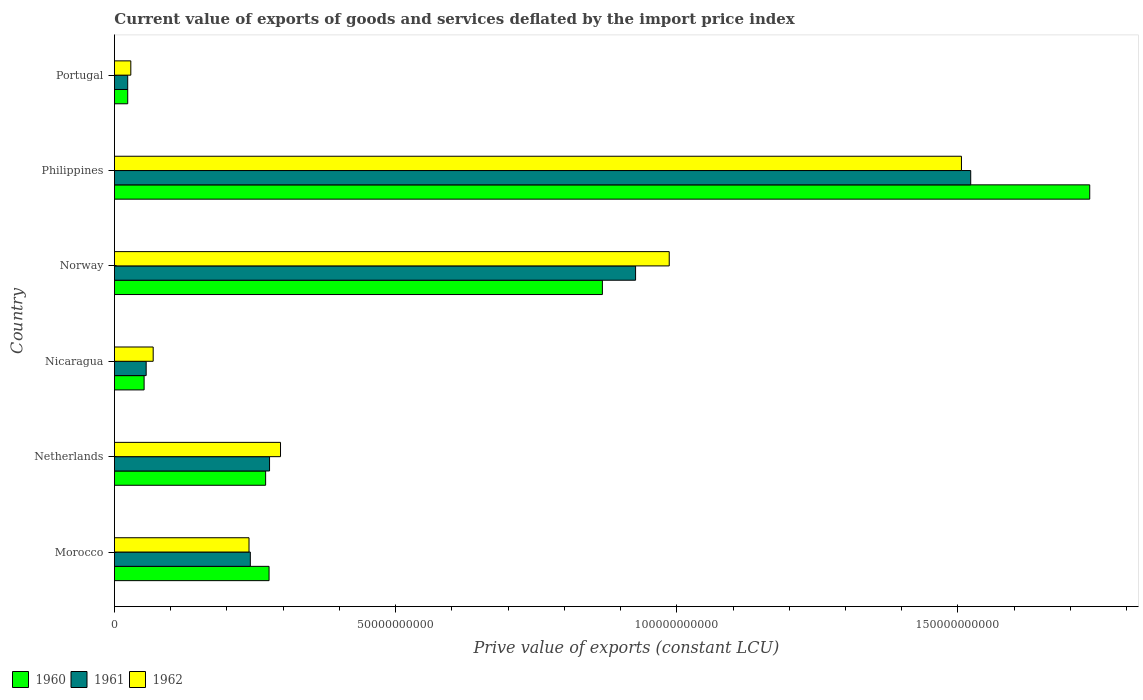How many groups of bars are there?
Make the answer very short. 6. How many bars are there on the 3rd tick from the bottom?
Give a very brief answer. 3. What is the prive value of exports in 1960 in Netherlands?
Make the answer very short. 2.69e+1. Across all countries, what is the maximum prive value of exports in 1962?
Keep it short and to the point. 1.51e+11. Across all countries, what is the minimum prive value of exports in 1960?
Offer a terse response. 2.36e+09. What is the total prive value of exports in 1961 in the graph?
Your response must be concise. 3.05e+11. What is the difference between the prive value of exports in 1962 in Netherlands and that in Norway?
Your answer should be very brief. -6.91e+1. What is the difference between the prive value of exports in 1962 in Philippines and the prive value of exports in 1961 in Portugal?
Provide a succinct answer. 1.48e+11. What is the average prive value of exports in 1962 per country?
Give a very brief answer. 5.21e+1. What is the difference between the prive value of exports in 1961 and prive value of exports in 1960 in Morocco?
Make the answer very short. -3.33e+09. In how many countries, is the prive value of exports in 1961 greater than 120000000000 LCU?
Ensure brevity in your answer.  1. What is the ratio of the prive value of exports in 1961 in Morocco to that in Netherlands?
Provide a short and direct response. 0.88. What is the difference between the highest and the second highest prive value of exports in 1961?
Provide a succinct answer. 5.96e+1. What is the difference between the highest and the lowest prive value of exports in 1962?
Make the answer very short. 1.48e+11. Is the sum of the prive value of exports in 1961 in Morocco and Portugal greater than the maximum prive value of exports in 1960 across all countries?
Your answer should be compact. No. What does the 2nd bar from the top in Philippines represents?
Offer a very short reply. 1961. What does the 1st bar from the bottom in Philippines represents?
Your answer should be compact. 1960. How many bars are there?
Ensure brevity in your answer.  18. How many countries are there in the graph?
Provide a short and direct response. 6. Are the values on the major ticks of X-axis written in scientific E-notation?
Give a very brief answer. No. Does the graph contain grids?
Your answer should be compact. No. What is the title of the graph?
Your answer should be very brief. Current value of exports of goods and services deflated by the import price index. What is the label or title of the X-axis?
Give a very brief answer. Prive value of exports (constant LCU). What is the Prive value of exports (constant LCU) of 1960 in Morocco?
Provide a short and direct response. 2.75e+1. What is the Prive value of exports (constant LCU) in 1961 in Morocco?
Ensure brevity in your answer.  2.42e+1. What is the Prive value of exports (constant LCU) of 1962 in Morocco?
Offer a terse response. 2.39e+1. What is the Prive value of exports (constant LCU) of 1960 in Netherlands?
Offer a terse response. 2.69e+1. What is the Prive value of exports (constant LCU) of 1961 in Netherlands?
Your answer should be very brief. 2.76e+1. What is the Prive value of exports (constant LCU) in 1962 in Netherlands?
Offer a very short reply. 2.95e+1. What is the Prive value of exports (constant LCU) of 1960 in Nicaragua?
Ensure brevity in your answer.  5.28e+09. What is the Prive value of exports (constant LCU) in 1961 in Nicaragua?
Provide a succinct answer. 5.65e+09. What is the Prive value of exports (constant LCU) in 1962 in Nicaragua?
Make the answer very short. 6.89e+09. What is the Prive value of exports (constant LCU) of 1960 in Norway?
Provide a short and direct response. 8.68e+1. What is the Prive value of exports (constant LCU) of 1961 in Norway?
Provide a succinct answer. 9.27e+1. What is the Prive value of exports (constant LCU) of 1962 in Norway?
Give a very brief answer. 9.87e+1. What is the Prive value of exports (constant LCU) of 1960 in Philippines?
Your response must be concise. 1.73e+11. What is the Prive value of exports (constant LCU) of 1961 in Philippines?
Offer a very short reply. 1.52e+11. What is the Prive value of exports (constant LCU) in 1962 in Philippines?
Your response must be concise. 1.51e+11. What is the Prive value of exports (constant LCU) in 1960 in Portugal?
Make the answer very short. 2.36e+09. What is the Prive value of exports (constant LCU) in 1961 in Portugal?
Offer a very short reply. 2.36e+09. What is the Prive value of exports (constant LCU) in 1962 in Portugal?
Ensure brevity in your answer.  2.91e+09. Across all countries, what is the maximum Prive value of exports (constant LCU) of 1960?
Offer a terse response. 1.73e+11. Across all countries, what is the maximum Prive value of exports (constant LCU) in 1961?
Give a very brief answer. 1.52e+11. Across all countries, what is the maximum Prive value of exports (constant LCU) of 1962?
Keep it short and to the point. 1.51e+11. Across all countries, what is the minimum Prive value of exports (constant LCU) in 1960?
Offer a very short reply. 2.36e+09. Across all countries, what is the minimum Prive value of exports (constant LCU) of 1961?
Your answer should be compact. 2.36e+09. Across all countries, what is the minimum Prive value of exports (constant LCU) in 1962?
Provide a short and direct response. 2.91e+09. What is the total Prive value of exports (constant LCU) in 1960 in the graph?
Keep it short and to the point. 3.22e+11. What is the total Prive value of exports (constant LCU) in 1961 in the graph?
Offer a terse response. 3.05e+11. What is the total Prive value of exports (constant LCU) in 1962 in the graph?
Keep it short and to the point. 3.13e+11. What is the difference between the Prive value of exports (constant LCU) of 1960 in Morocco and that in Netherlands?
Offer a terse response. 6.10e+08. What is the difference between the Prive value of exports (constant LCU) of 1961 in Morocco and that in Netherlands?
Give a very brief answer. -3.42e+09. What is the difference between the Prive value of exports (constant LCU) in 1962 in Morocco and that in Netherlands?
Ensure brevity in your answer.  -5.60e+09. What is the difference between the Prive value of exports (constant LCU) in 1960 in Morocco and that in Nicaragua?
Make the answer very short. 2.22e+1. What is the difference between the Prive value of exports (constant LCU) in 1961 in Morocco and that in Nicaragua?
Keep it short and to the point. 1.85e+1. What is the difference between the Prive value of exports (constant LCU) in 1962 in Morocco and that in Nicaragua?
Offer a terse response. 1.70e+1. What is the difference between the Prive value of exports (constant LCU) of 1960 in Morocco and that in Norway?
Make the answer very short. -5.93e+1. What is the difference between the Prive value of exports (constant LCU) of 1961 in Morocco and that in Norway?
Provide a succinct answer. -6.85e+1. What is the difference between the Prive value of exports (constant LCU) in 1962 in Morocco and that in Norway?
Offer a very short reply. -7.47e+1. What is the difference between the Prive value of exports (constant LCU) in 1960 in Morocco and that in Philippines?
Provide a succinct answer. -1.46e+11. What is the difference between the Prive value of exports (constant LCU) in 1961 in Morocco and that in Philippines?
Offer a terse response. -1.28e+11. What is the difference between the Prive value of exports (constant LCU) in 1962 in Morocco and that in Philippines?
Ensure brevity in your answer.  -1.27e+11. What is the difference between the Prive value of exports (constant LCU) of 1960 in Morocco and that in Portugal?
Make the answer very short. 2.51e+1. What is the difference between the Prive value of exports (constant LCU) in 1961 in Morocco and that in Portugal?
Provide a short and direct response. 2.18e+1. What is the difference between the Prive value of exports (constant LCU) of 1962 in Morocco and that in Portugal?
Your response must be concise. 2.10e+1. What is the difference between the Prive value of exports (constant LCU) in 1960 in Netherlands and that in Nicaragua?
Ensure brevity in your answer.  2.16e+1. What is the difference between the Prive value of exports (constant LCU) of 1961 in Netherlands and that in Nicaragua?
Keep it short and to the point. 2.19e+1. What is the difference between the Prive value of exports (constant LCU) in 1962 in Netherlands and that in Nicaragua?
Make the answer very short. 2.26e+1. What is the difference between the Prive value of exports (constant LCU) in 1960 in Netherlands and that in Norway?
Offer a terse response. -5.99e+1. What is the difference between the Prive value of exports (constant LCU) in 1961 in Netherlands and that in Norway?
Provide a succinct answer. -6.51e+1. What is the difference between the Prive value of exports (constant LCU) in 1962 in Netherlands and that in Norway?
Keep it short and to the point. -6.91e+1. What is the difference between the Prive value of exports (constant LCU) in 1960 in Netherlands and that in Philippines?
Your answer should be very brief. -1.47e+11. What is the difference between the Prive value of exports (constant LCU) in 1961 in Netherlands and that in Philippines?
Give a very brief answer. -1.25e+11. What is the difference between the Prive value of exports (constant LCU) of 1962 in Netherlands and that in Philippines?
Your answer should be compact. -1.21e+11. What is the difference between the Prive value of exports (constant LCU) in 1960 in Netherlands and that in Portugal?
Your response must be concise. 2.45e+1. What is the difference between the Prive value of exports (constant LCU) in 1961 in Netherlands and that in Portugal?
Offer a terse response. 2.52e+1. What is the difference between the Prive value of exports (constant LCU) in 1962 in Netherlands and that in Portugal?
Provide a succinct answer. 2.66e+1. What is the difference between the Prive value of exports (constant LCU) of 1960 in Nicaragua and that in Norway?
Make the answer very short. -8.15e+1. What is the difference between the Prive value of exports (constant LCU) of 1961 in Nicaragua and that in Norway?
Give a very brief answer. -8.70e+1. What is the difference between the Prive value of exports (constant LCU) of 1962 in Nicaragua and that in Norway?
Offer a very short reply. -9.18e+1. What is the difference between the Prive value of exports (constant LCU) of 1960 in Nicaragua and that in Philippines?
Offer a terse response. -1.68e+11. What is the difference between the Prive value of exports (constant LCU) of 1961 in Nicaragua and that in Philippines?
Offer a terse response. -1.47e+11. What is the difference between the Prive value of exports (constant LCU) in 1962 in Nicaragua and that in Philippines?
Your answer should be very brief. -1.44e+11. What is the difference between the Prive value of exports (constant LCU) in 1960 in Nicaragua and that in Portugal?
Make the answer very short. 2.92e+09. What is the difference between the Prive value of exports (constant LCU) of 1961 in Nicaragua and that in Portugal?
Ensure brevity in your answer.  3.29e+09. What is the difference between the Prive value of exports (constant LCU) of 1962 in Nicaragua and that in Portugal?
Make the answer very short. 3.98e+09. What is the difference between the Prive value of exports (constant LCU) of 1960 in Norway and that in Philippines?
Offer a terse response. -8.67e+1. What is the difference between the Prive value of exports (constant LCU) of 1961 in Norway and that in Philippines?
Your answer should be compact. -5.96e+1. What is the difference between the Prive value of exports (constant LCU) of 1962 in Norway and that in Philippines?
Give a very brief answer. -5.20e+1. What is the difference between the Prive value of exports (constant LCU) in 1960 in Norway and that in Portugal?
Ensure brevity in your answer.  8.44e+1. What is the difference between the Prive value of exports (constant LCU) in 1961 in Norway and that in Portugal?
Your response must be concise. 9.03e+1. What is the difference between the Prive value of exports (constant LCU) of 1962 in Norway and that in Portugal?
Your answer should be compact. 9.57e+1. What is the difference between the Prive value of exports (constant LCU) in 1960 in Philippines and that in Portugal?
Keep it short and to the point. 1.71e+11. What is the difference between the Prive value of exports (constant LCU) of 1961 in Philippines and that in Portugal?
Give a very brief answer. 1.50e+11. What is the difference between the Prive value of exports (constant LCU) of 1962 in Philippines and that in Portugal?
Give a very brief answer. 1.48e+11. What is the difference between the Prive value of exports (constant LCU) in 1960 in Morocco and the Prive value of exports (constant LCU) in 1961 in Netherlands?
Keep it short and to the point. -8.70e+07. What is the difference between the Prive value of exports (constant LCU) of 1960 in Morocco and the Prive value of exports (constant LCU) of 1962 in Netherlands?
Your response must be concise. -2.04e+09. What is the difference between the Prive value of exports (constant LCU) of 1961 in Morocco and the Prive value of exports (constant LCU) of 1962 in Netherlands?
Give a very brief answer. -5.37e+09. What is the difference between the Prive value of exports (constant LCU) in 1960 in Morocco and the Prive value of exports (constant LCU) in 1961 in Nicaragua?
Provide a succinct answer. 2.19e+1. What is the difference between the Prive value of exports (constant LCU) of 1960 in Morocco and the Prive value of exports (constant LCU) of 1962 in Nicaragua?
Give a very brief answer. 2.06e+1. What is the difference between the Prive value of exports (constant LCU) of 1961 in Morocco and the Prive value of exports (constant LCU) of 1962 in Nicaragua?
Keep it short and to the point. 1.73e+1. What is the difference between the Prive value of exports (constant LCU) in 1960 in Morocco and the Prive value of exports (constant LCU) in 1961 in Norway?
Provide a succinct answer. -6.52e+1. What is the difference between the Prive value of exports (constant LCU) in 1960 in Morocco and the Prive value of exports (constant LCU) in 1962 in Norway?
Provide a short and direct response. -7.12e+1. What is the difference between the Prive value of exports (constant LCU) in 1961 in Morocco and the Prive value of exports (constant LCU) in 1962 in Norway?
Keep it short and to the point. -7.45e+1. What is the difference between the Prive value of exports (constant LCU) in 1960 in Morocco and the Prive value of exports (constant LCU) in 1961 in Philippines?
Your answer should be compact. -1.25e+11. What is the difference between the Prive value of exports (constant LCU) in 1960 in Morocco and the Prive value of exports (constant LCU) in 1962 in Philippines?
Make the answer very short. -1.23e+11. What is the difference between the Prive value of exports (constant LCU) of 1961 in Morocco and the Prive value of exports (constant LCU) of 1962 in Philippines?
Offer a terse response. -1.26e+11. What is the difference between the Prive value of exports (constant LCU) in 1960 in Morocco and the Prive value of exports (constant LCU) in 1961 in Portugal?
Your answer should be very brief. 2.51e+1. What is the difference between the Prive value of exports (constant LCU) in 1960 in Morocco and the Prive value of exports (constant LCU) in 1962 in Portugal?
Provide a short and direct response. 2.46e+1. What is the difference between the Prive value of exports (constant LCU) of 1961 in Morocco and the Prive value of exports (constant LCU) of 1962 in Portugal?
Keep it short and to the point. 2.13e+1. What is the difference between the Prive value of exports (constant LCU) of 1960 in Netherlands and the Prive value of exports (constant LCU) of 1961 in Nicaragua?
Offer a very short reply. 2.12e+1. What is the difference between the Prive value of exports (constant LCU) in 1960 in Netherlands and the Prive value of exports (constant LCU) in 1962 in Nicaragua?
Your answer should be compact. 2.00e+1. What is the difference between the Prive value of exports (constant LCU) of 1961 in Netherlands and the Prive value of exports (constant LCU) of 1962 in Nicaragua?
Keep it short and to the point. 2.07e+1. What is the difference between the Prive value of exports (constant LCU) of 1960 in Netherlands and the Prive value of exports (constant LCU) of 1961 in Norway?
Provide a short and direct response. -6.58e+1. What is the difference between the Prive value of exports (constant LCU) in 1960 in Netherlands and the Prive value of exports (constant LCU) in 1962 in Norway?
Your answer should be very brief. -7.18e+1. What is the difference between the Prive value of exports (constant LCU) in 1961 in Netherlands and the Prive value of exports (constant LCU) in 1962 in Norway?
Keep it short and to the point. -7.11e+1. What is the difference between the Prive value of exports (constant LCU) in 1960 in Netherlands and the Prive value of exports (constant LCU) in 1961 in Philippines?
Offer a terse response. -1.25e+11. What is the difference between the Prive value of exports (constant LCU) of 1960 in Netherlands and the Prive value of exports (constant LCU) of 1962 in Philippines?
Provide a succinct answer. -1.24e+11. What is the difference between the Prive value of exports (constant LCU) in 1961 in Netherlands and the Prive value of exports (constant LCU) in 1962 in Philippines?
Your response must be concise. -1.23e+11. What is the difference between the Prive value of exports (constant LCU) in 1960 in Netherlands and the Prive value of exports (constant LCU) in 1961 in Portugal?
Your answer should be compact. 2.45e+1. What is the difference between the Prive value of exports (constant LCU) of 1960 in Netherlands and the Prive value of exports (constant LCU) of 1962 in Portugal?
Give a very brief answer. 2.40e+1. What is the difference between the Prive value of exports (constant LCU) in 1961 in Netherlands and the Prive value of exports (constant LCU) in 1962 in Portugal?
Offer a terse response. 2.47e+1. What is the difference between the Prive value of exports (constant LCU) of 1960 in Nicaragua and the Prive value of exports (constant LCU) of 1961 in Norway?
Your answer should be very brief. -8.74e+1. What is the difference between the Prive value of exports (constant LCU) of 1960 in Nicaragua and the Prive value of exports (constant LCU) of 1962 in Norway?
Offer a very short reply. -9.34e+1. What is the difference between the Prive value of exports (constant LCU) in 1961 in Nicaragua and the Prive value of exports (constant LCU) in 1962 in Norway?
Your response must be concise. -9.30e+1. What is the difference between the Prive value of exports (constant LCU) of 1960 in Nicaragua and the Prive value of exports (constant LCU) of 1961 in Philippines?
Provide a succinct answer. -1.47e+11. What is the difference between the Prive value of exports (constant LCU) in 1960 in Nicaragua and the Prive value of exports (constant LCU) in 1962 in Philippines?
Offer a terse response. -1.45e+11. What is the difference between the Prive value of exports (constant LCU) in 1961 in Nicaragua and the Prive value of exports (constant LCU) in 1962 in Philippines?
Provide a succinct answer. -1.45e+11. What is the difference between the Prive value of exports (constant LCU) of 1960 in Nicaragua and the Prive value of exports (constant LCU) of 1961 in Portugal?
Offer a very short reply. 2.92e+09. What is the difference between the Prive value of exports (constant LCU) of 1960 in Nicaragua and the Prive value of exports (constant LCU) of 1962 in Portugal?
Your answer should be compact. 2.37e+09. What is the difference between the Prive value of exports (constant LCU) in 1961 in Nicaragua and the Prive value of exports (constant LCU) in 1962 in Portugal?
Ensure brevity in your answer.  2.73e+09. What is the difference between the Prive value of exports (constant LCU) in 1960 in Norway and the Prive value of exports (constant LCU) in 1961 in Philippines?
Give a very brief answer. -6.55e+1. What is the difference between the Prive value of exports (constant LCU) of 1960 in Norway and the Prive value of exports (constant LCU) of 1962 in Philippines?
Your answer should be compact. -6.39e+1. What is the difference between the Prive value of exports (constant LCU) of 1961 in Norway and the Prive value of exports (constant LCU) of 1962 in Philippines?
Your answer should be very brief. -5.79e+1. What is the difference between the Prive value of exports (constant LCU) in 1960 in Norway and the Prive value of exports (constant LCU) in 1961 in Portugal?
Your answer should be compact. 8.44e+1. What is the difference between the Prive value of exports (constant LCU) in 1960 in Norway and the Prive value of exports (constant LCU) in 1962 in Portugal?
Ensure brevity in your answer.  8.39e+1. What is the difference between the Prive value of exports (constant LCU) in 1961 in Norway and the Prive value of exports (constant LCU) in 1962 in Portugal?
Ensure brevity in your answer.  8.98e+1. What is the difference between the Prive value of exports (constant LCU) in 1960 in Philippines and the Prive value of exports (constant LCU) in 1961 in Portugal?
Provide a succinct answer. 1.71e+11. What is the difference between the Prive value of exports (constant LCU) in 1960 in Philippines and the Prive value of exports (constant LCU) in 1962 in Portugal?
Ensure brevity in your answer.  1.71e+11. What is the difference between the Prive value of exports (constant LCU) in 1961 in Philippines and the Prive value of exports (constant LCU) in 1962 in Portugal?
Ensure brevity in your answer.  1.49e+11. What is the average Prive value of exports (constant LCU) in 1960 per country?
Provide a succinct answer. 5.37e+1. What is the average Prive value of exports (constant LCU) in 1961 per country?
Give a very brief answer. 5.08e+1. What is the average Prive value of exports (constant LCU) of 1962 per country?
Ensure brevity in your answer.  5.21e+1. What is the difference between the Prive value of exports (constant LCU) of 1960 and Prive value of exports (constant LCU) of 1961 in Morocco?
Your answer should be compact. 3.33e+09. What is the difference between the Prive value of exports (constant LCU) in 1960 and Prive value of exports (constant LCU) in 1962 in Morocco?
Your answer should be very brief. 3.56e+09. What is the difference between the Prive value of exports (constant LCU) of 1961 and Prive value of exports (constant LCU) of 1962 in Morocco?
Ensure brevity in your answer.  2.33e+08. What is the difference between the Prive value of exports (constant LCU) in 1960 and Prive value of exports (constant LCU) in 1961 in Netherlands?
Your response must be concise. -6.97e+08. What is the difference between the Prive value of exports (constant LCU) in 1960 and Prive value of exports (constant LCU) in 1962 in Netherlands?
Offer a terse response. -2.65e+09. What is the difference between the Prive value of exports (constant LCU) in 1961 and Prive value of exports (constant LCU) in 1962 in Netherlands?
Make the answer very short. -1.95e+09. What is the difference between the Prive value of exports (constant LCU) in 1960 and Prive value of exports (constant LCU) in 1961 in Nicaragua?
Your answer should be very brief. -3.67e+08. What is the difference between the Prive value of exports (constant LCU) of 1960 and Prive value of exports (constant LCU) of 1962 in Nicaragua?
Keep it short and to the point. -1.61e+09. What is the difference between the Prive value of exports (constant LCU) in 1961 and Prive value of exports (constant LCU) in 1962 in Nicaragua?
Offer a very short reply. -1.25e+09. What is the difference between the Prive value of exports (constant LCU) of 1960 and Prive value of exports (constant LCU) of 1961 in Norway?
Your answer should be compact. -5.90e+09. What is the difference between the Prive value of exports (constant LCU) in 1960 and Prive value of exports (constant LCU) in 1962 in Norway?
Your answer should be very brief. -1.19e+1. What is the difference between the Prive value of exports (constant LCU) in 1961 and Prive value of exports (constant LCU) in 1962 in Norway?
Your response must be concise. -5.98e+09. What is the difference between the Prive value of exports (constant LCU) of 1960 and Prive value of exports (constant LCU) of 1961 in Philippines?
Your answer should be very brief. 2.12e+1. What is the difference between the Prive value of exports (constant LCU) in 1960 and Prive value of exports (constant LCU) in 1962 in Philippines?
Keep it short and to the point. 2.28e+1. What is the difference between the Prive value of exports (constant LCU) in 1961 and Prive value of exports (constant LCU) in 1962 in Philippines?
Provide a short and direct response. 1.65e+09. What is the difference between the Prive value of exports (constant LCU) in 1960 and Prive value of exports (constant LCU) in 1961 in Portugal?
Offer a terse response. 2.01e+06. What is the difference between the Prive value of exports (constant LCU) in 1960 and Prive value of exports (constant LCU) in 1962 in Portugal?
Make the answer very short. -5.51e+08. What is the difference between the Prive value of exports (constant LCU) of 1961 and Prive value of exports (constant LCU) of 1962 in Portugal?
Make the answer very short. -5.53e+08. What is the ratio of the Prive value of exports (constant LCU) in 1960 in Morocco to that in Netherlands?
Make the answer very short. 1.02. What is the ratio of the Prive value of exports (constant LCU) of 1961 in Morocco to that in Netherlands?
Your answer should be compact. 0.88. What is the ratio of the Prive value of exports (constant LCU) in 1962 in Morocco to that in Netherlands?
Offer a very short reply. 0.81. What is the ratio of the Prive value of exports (constant LCU) in 1960 in Morocco to that in Nicaragua?
Offer a terse response. 5.21. What is the ratio of the Prive value of exports (constant LCU) in 1961 in Morocco to that in Nicaragua?
Give a very brief answer. 4.28. What is the ratio of the Prive value of exports (constant LCU) in 1962 in Morocco to that in Nicaragua?
Keep it short and to the point. 3.47. What is the ratio of the Prive value of exports (constant LCU) of 1960 in Morocco to that in Norway?
Ensure brevity in your answer.  0.32. What is the ratio of the Prive value of exports (constant LCU) in 1961 in Morocco to that in Norway?
Provide a succinct answer. 0.26. What is the ratio of the Prive value of exports (constant LCU) in 1962 in Morocco to that in Norway?
Ensure brevity in your answer.  0.24. What is the ratio of the Prive value of exports (constant LCU) of 1960 in Morocco to that in Philippines?
Your answer should be compact. 0.16. What is the ratio of the Prive value of exports (constant LCU) in 1961 in Morocco to that in Philippines?
Your answer should be very brief. 0.16. What is the ratio of the Prive value of exports (constant LCU) in 1962 in Morocco to that in Philippines?
Your answer should be very brief. 0.16. What is the ratio of the Prive value of exports (constant LCU) in 1960 in Morocco to that in Portugal?
Offer a very short reply. 11.64. What is the ratio of the Prive value of exports (constant LCU) in 1961 in Morocco to that in Portugal?
Your answer should be compact. 10.24. What is the ratio of the Prive value of exports (constant LCU) in 1962 in Morocco to that in Portugal?
Your answer should be very brief. 8.22. What is the ratio of the Prive value of exports (constant LCU) in 1960 in Netherlands to that in Nicaragua?
Provide a short and direct response. 5.09. What is the ratio of the Prive value of exports (constant LCU) of 1961 in Netherlands to that in Nicaragua?
Keep it short and to the point. 4.89. What is the ratio of the Prive value of exports (constant LCU) in 1962 in Netherlands to that in Nicaragua?
Keep it short and to the point. 4.29. What is the ratio of the Prive value of exports (constant LCU) of 1960 in Netherlands to that in Norway?
Provide a short and direct response. 0.31. What is the ratio of the Prive value of exports (constant LCU) of 1961 in Netherlands to that in Norway?
Your response must be concise. 0.3. What is the ratio of the Prive value of exports (constant LCU) of 1962 in Netherlands to that in Norway?
Your answer should be very brief. 0.3. What is the ratio of the Prive value of exports (constant LCU) in 1960 in Netherlands to that in Philippines?
Provide a short and direct response. 0.15. What is the ratio of the Prive value of exports (constant LCU) of 1961 in Netherlands to that in Philippines?
Your answer should be compact. 0.18. What is the ratio of the Prive value of exports (constant LCU) in 1962 in Netherlands to that in Philippines?
Your answer should be compact. 0.2. What is the ratio of the Prive value of exports (constant LCU) of 1960 in Netherlands to that in Portugal?
Offer a terse response. 11.38. What is the ratio of the Prive value of exports (constant LCU) of 1961 in Netherlands to that in Portugal?
Offer a very short reply. 11.69. What is the ratio of the Prive value of exports (constant LCU) of 1962 in Netherlands to that in Portugal?
Keep it short and to the point. 10.14. What is the ratio of the Prive value of exports (constant LCU) of 1960 in Nicaragua to that in Norway?
Your answer should be very brief. 0.06. What is the ratio of the Prive value of exports (constant LCU) in 1961 in Nicaragua to that in Norway?
Your answer should be very brief. 0.06. What is the ratio of the Prive value of exports (constant LCU) in 1962 in Nicaragua to that in Norway?
Provide a succinct answer. 0.07. What is the ratio of the Prive value of exports (constant LCU) of 1960 in Nicaragua to that in Philippines?
Your answer should be compact. 0.03. What is the ratio of the Prive value of exports (constant LCU) of 1961 in Nicaragua to that in Philippines?
Give a very brief answer. 0.04. What is the ratio of the Prive value of exports (constant LCU) of 1962 in Nicaragua to that in Philippines?
Offer a very short reply. 0.05. What is the ratio of the Prive value of exports (constant LCU) of 1960 in Nicaragua to that in Portugal?
Ensure brevity in your answer.  2.23. What is the ratio of the Prive value of exports (constant LCU) in 1961 in Nicaragua to that in Portugal?
Give a very brief answer. 2.39. What is the ratio of the Prive value of exports (constant LCU) of 1962 in Nicaragua to that in Portugal?
Provide a short and direct response. 2.37. What is the ratio of the Prive value of exports (constant LCU) in 1960 in Norway to that in Philippines?
Ensure brevity in your answer.  0.5. What is the ratio of the Prive value of exports (constant LCU) of 1961 in Norway to that in Philippines?
Offer a very short reply. 0.61. What is the ratio of the Prive value of exports (constant LCU) in 1962 in Norway to that in Philippines?
Make the answer very short. 0.66. What is the ratio of the Prive value of exports (constant LCU) in 1960 in Norway to that in Portugal?
Offer a very short reply. 36.73. What is the ratio of the Prive value of exports (constant LCU) in 1961 in Norway to that in Portugal?
Ensure brevity in your answer.  39.27. What is the ratio of the Prive value of exports (constant LCU) in 1962 in Norway to that in Portugal?
Make the answer very short. 33.87. What is the ratio of the Prive value of exports (constant LCU) in 1960 in Philippines to that in Portugal?
Keep it short and to the point. 73.42. What is the ratio of the Prive value of exports (constant LCU) of 1961 in Philippines to that in Portugal?
Make the answer very short. 64.52. What is the ratio of the Prive value of exports (constant LCU) of 1962 in Philippines to that in Portugal?
Make the answer very short. 51.71. What is the difference between the highest and the second highest Prive value of exports (constant LCU) of 1960?
Make the answer very short. 8.67e+1. What is the difference between the highest and the second highest Prive value of exports (constant LCU) of 1961?
Offer a terse response. 5.96e+1. What is the difference between the highest and the second highest Prive value of exports (constant LCU) of 1962?
Offer a terse response. 5.20e+1. What is the difference between the highest and the lowest Prive value of exports (constant LCU) in 1960?
Your response must be concise. 1.71e+11. What is the difference between the highest and the lowest Prive value of exports (constant LCU) of 1961?
Your answer should be compact. 1.50e+11. What is the difference between the highest and the lowest Prive value of exports (constant LCU) in 1962?
Provide a succinct answer. 1.48e+11. 